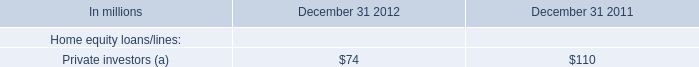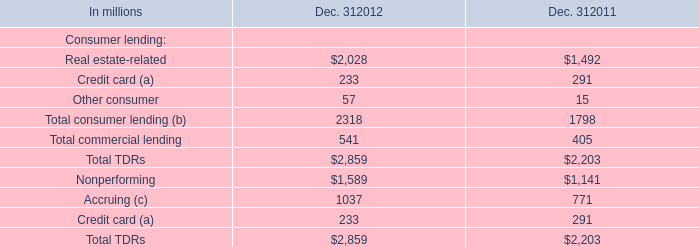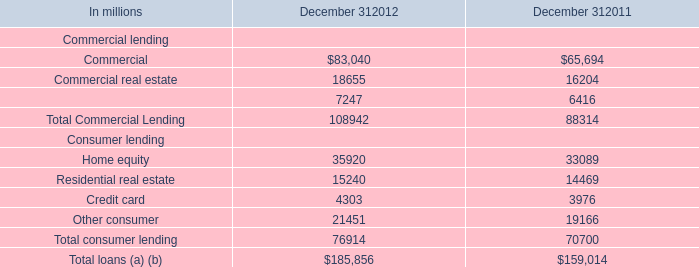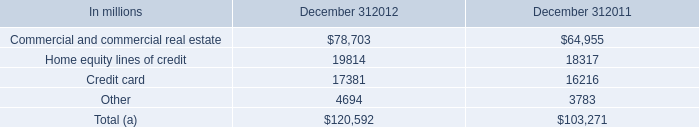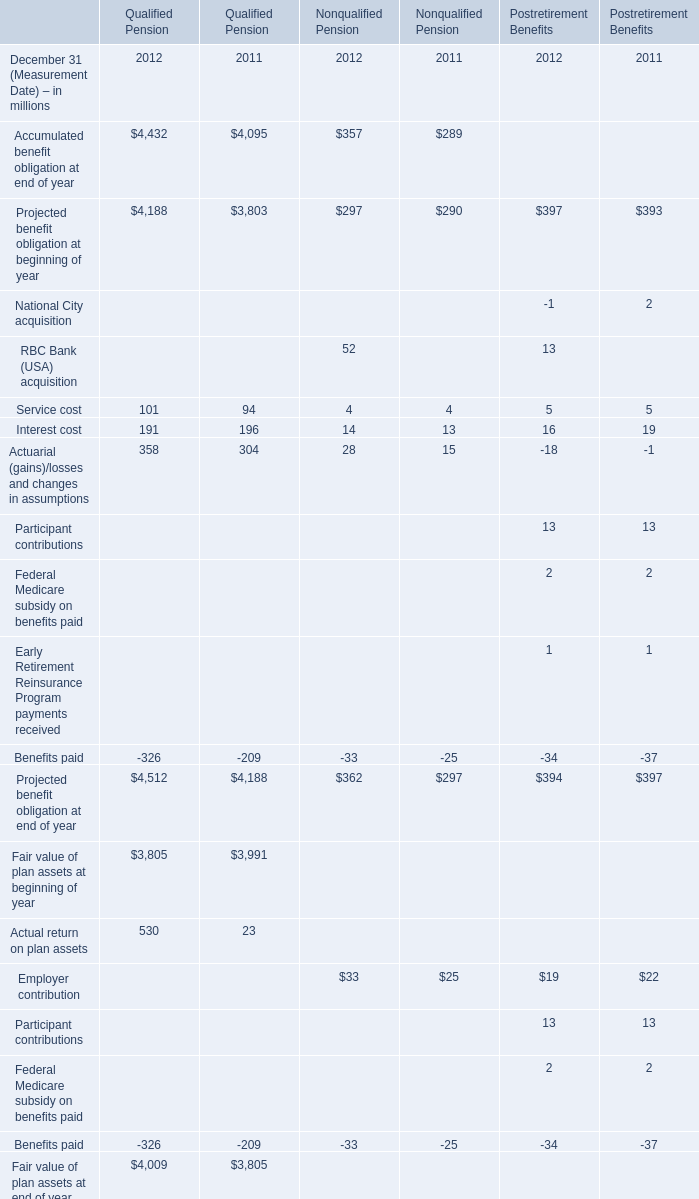What is the average amount of Other consumer Consumer lending of December 312012, and Nonperforming of Dec. 312011 ? 
Computations: ((21451.0 + 1141.0) / 2)
Answer: 11296.0. 